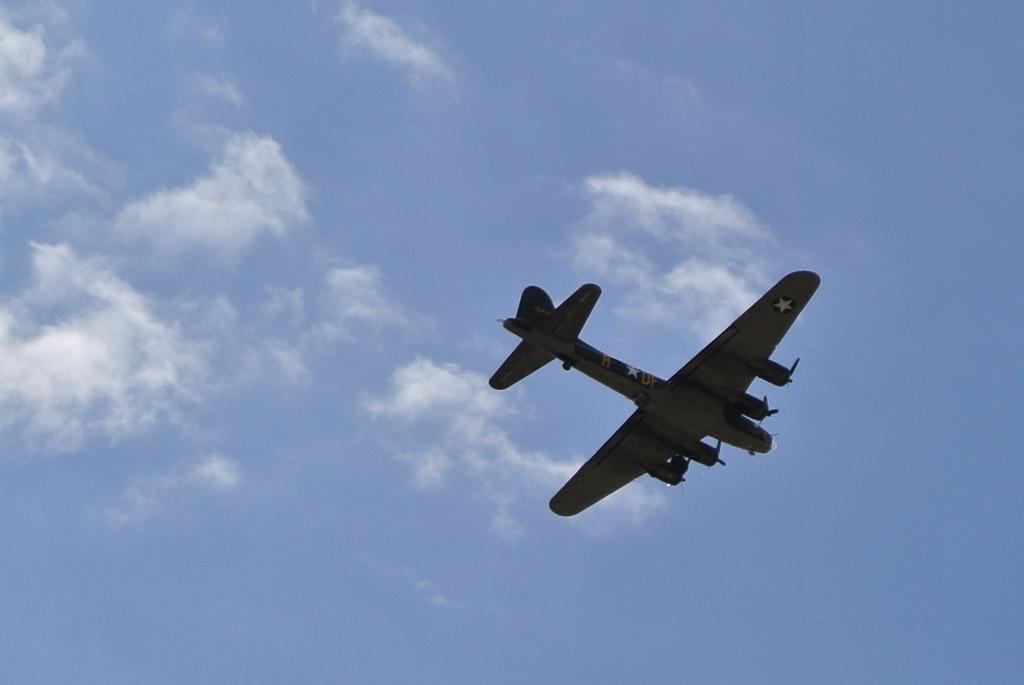What is the main subject of the image? The main subject of the image is an aircraft. What is the aircraft doing in the image? The aircraft is flying in the sky. What can be seen in the sky besides the aircraft? There are clouds in the sky. What type of rhythm can be heard coming from the lake in the image? There is no lake present in the image, so it's not possible to determine what, if any, rhythm might be heard. 